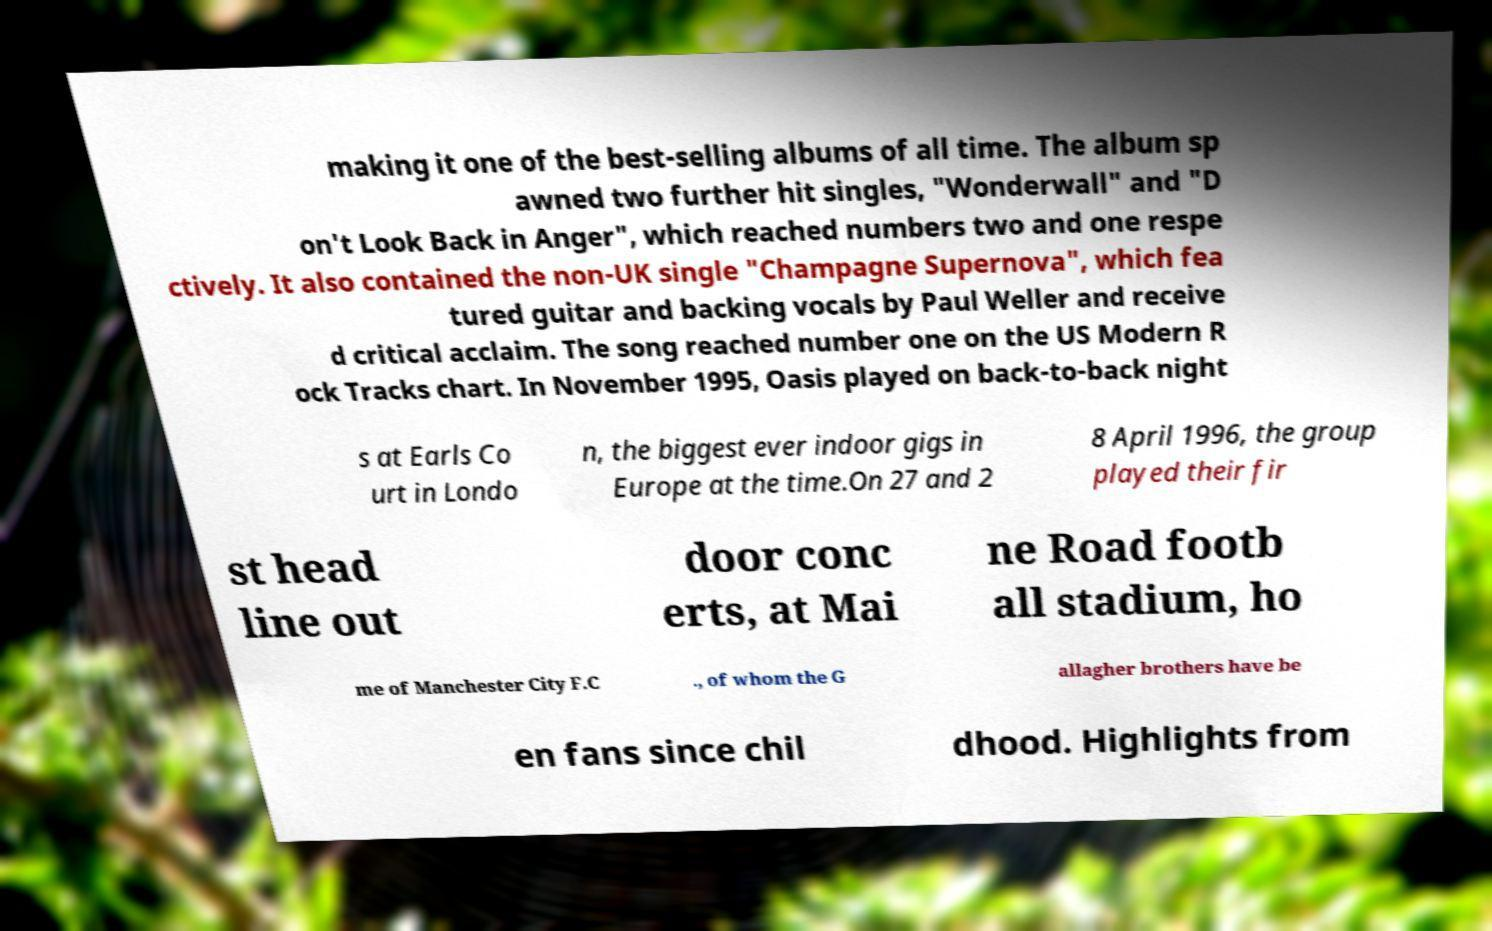Could you assist in decoding the text presented in this image and type it out clearly? making it one of the best-selling albums of all time. The album sp awned two further hit singles, "Wonderwall" and "D on't Look Back in Anger", which reached numbers two and one respe ctively. It also contained the non-UK single "Champagne Supernova", which fea tured guitar and backing vocals by Paul Weller and receive d critical acclaim. The song reached number one on the US Modern R ock Tracks chart. In November 1995, Oasis played on back-to-back night s at Earls Co urt in Londo n, the biggest ever indoor gigs in Europe at the time.On 27 and 2 8 April 1996, the group played their fir st head line out door conc erts, at Mai ne Road footb all stadium, ho me of Manchester City F.C ., of whom the G allagher brothers have be en fans since chil dhood. Highlights from 